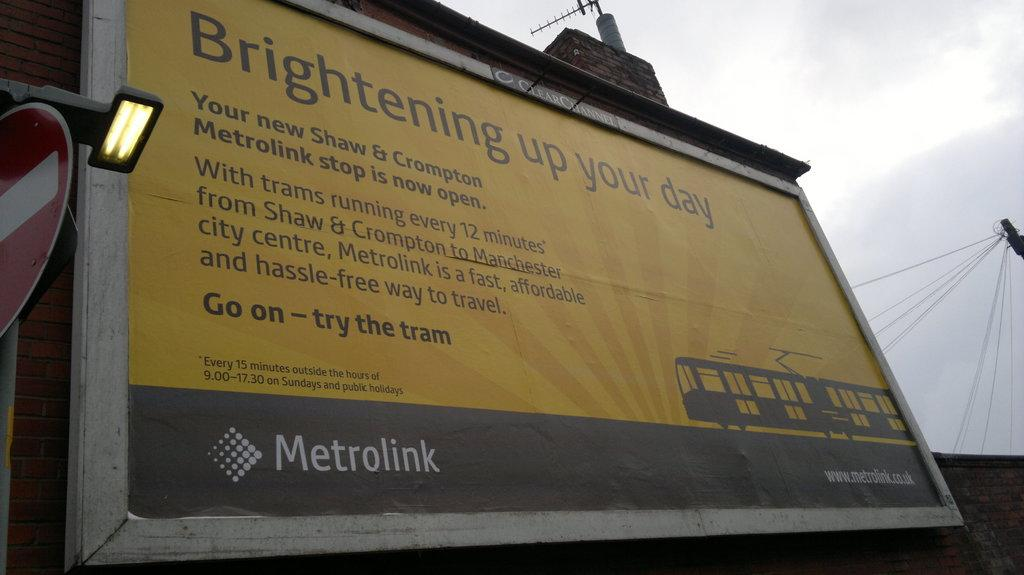Provide a one-sentence caption for the provided image. A big poster explaining how Metrolink will brighten your day on a cloudy day. 